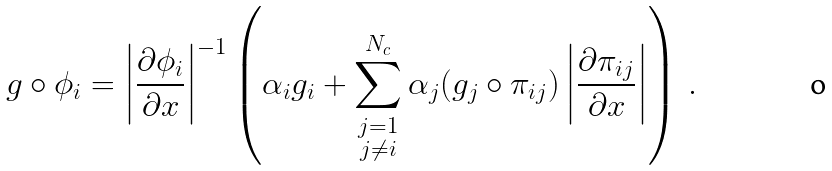Convert formula to latex. <formula><loc_0><loc_0><loc_500><loc_500>g \circ \phi _ { i } = \left | \frac { \partial \phi _ { i } } { \partial x } \right | ^ { - 1 } \left ( \alpha _ { i } g _ { i } + \sum _ { \substack { j = 1 \\ j \not = i } } ^ { N _ { c } } \alpha _ { j } ( g _ { j } \circ \pi _ { i j } ) \left | \frac { \partial \pi _ { i j } } { \partial x } \right | \right ) \, .</formula> 